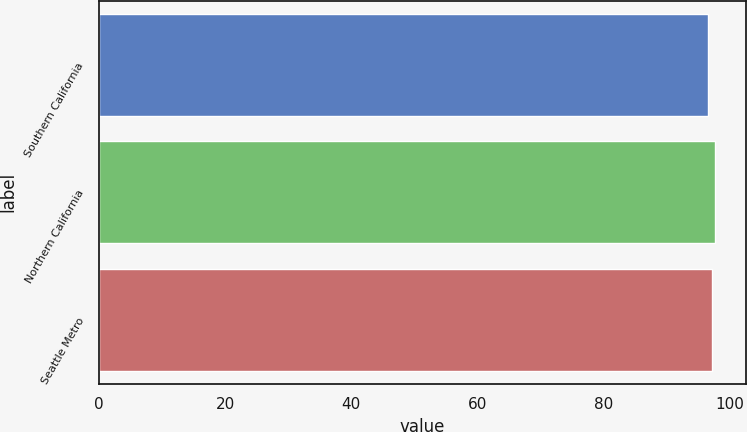Convert chart. <chart><loc_0><loc_0><loc_500><loc_500><bar_chart><fcel>Southern California<fcel>Northern California<fcel>Seattle Metro<nl><fcel>96.6<fcel>97.7<fcel>97.1<nl></chart> 